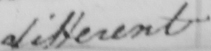Can you read and transcribe this handwriting? different 